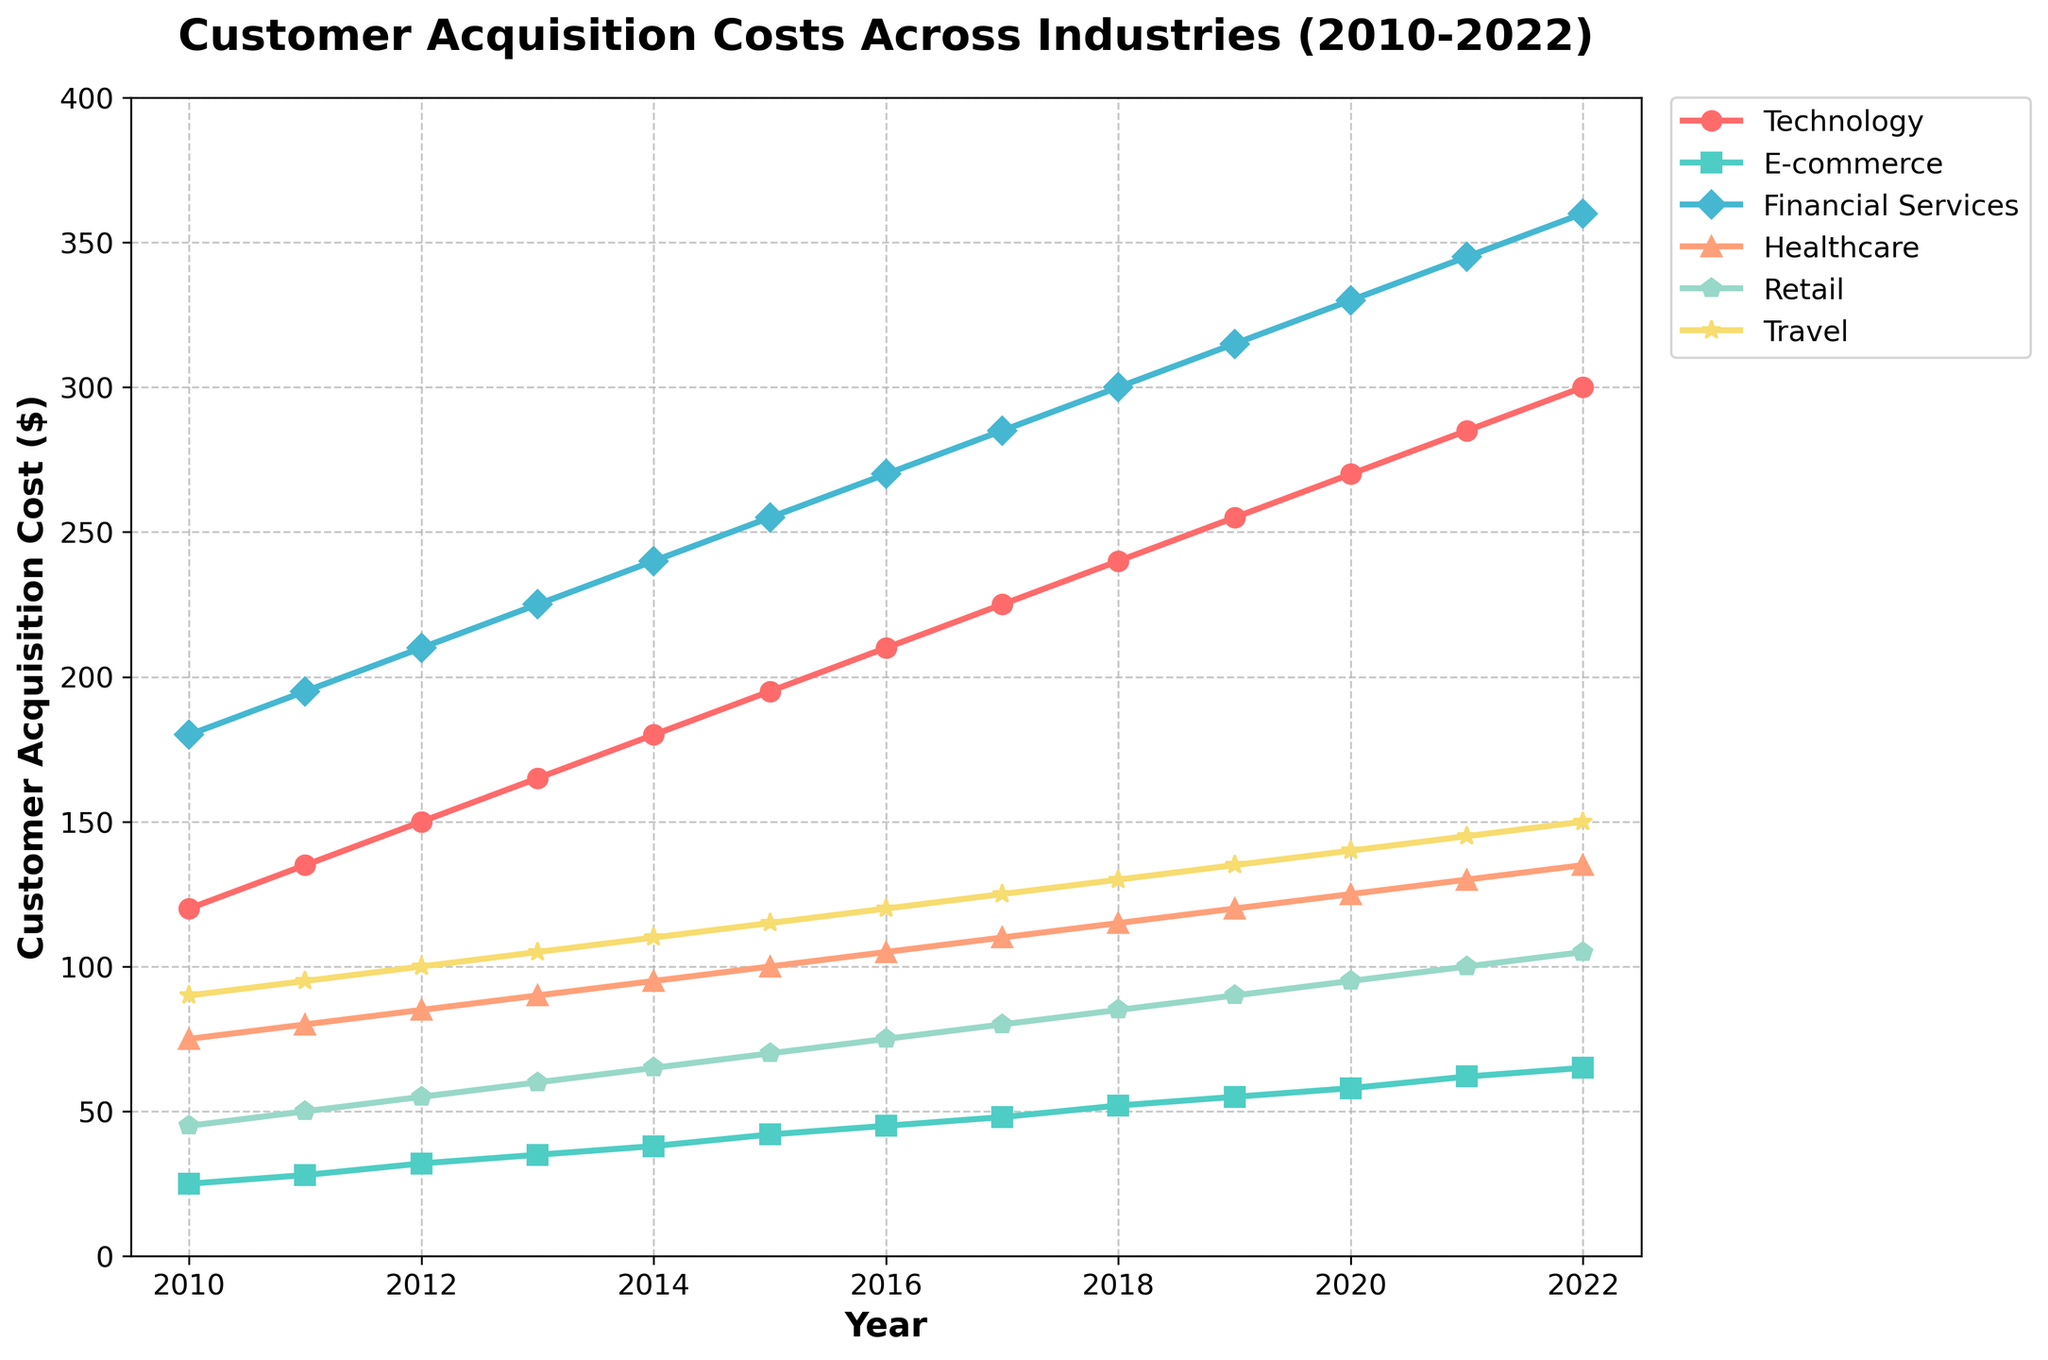What industry had the highest customer acquisition cost in 2022? By looking at the last data point for each industry, Healthcare had the highest customer acquisition cost in 2022 at $360.
Answer: Healthcare Which industry had the smallest increase in customer acquisition costs between 2010 and 2022? Subtracting the 2010 value from the 2022 value for each industry: Technology (300-120=180), E-commerce (65-25=40), Financial Services (360-180=180), Healthcare (135-75=60), Retail (105-45=60), Travel (150-90=60). E-commerce had the smallest increase (40).
Answer: E-commerce What is the trend in customer acquisition costs for the Retail industry from 2010 to 2022? The line for Retail rises steadily from 45 in 2010 to 105 in 2022.
Answer: Increasing By how much did the customer acquisition cost for the Technology industry increase from 2019 to 2022? In 2019, the cost was $255 and in 2022 it was $300. The increase is 300 - 255 = 45.
Answer: 45 Which industry showed the most consistent increase in customer acquisition costs over the years? All lines display an increasing trend, but Technology shows a very steady and consistent increase without any sharp spikes or dips.
Answer: Technology Between 2010 and 2020, what was the average customer acquisition cost for Financial Services? Summing the costs for Financial Services from 2010 to 2020: 180 + 195 + 210 + 225 + 240 + 255 + 270 + 285 + 300 + 315 + 330 = 2805. Dividing by the number of years (11), the average is 2805 / 11 ≈ 255.
Answer: 255 What color line represents the Travel industry? The line representing the Travel industry is yellow.
Answer: Yellow Compare the customer acquisition costs for E-commerce and Retail in 2015. Which industry had higher costs? In 2015, E-commerce is at $42 and Retail is at $70. Retail had higher costs.
Answer: Retail By how much did the Healthcare industry's customer acquisition cost change from 2015 to 2022? In 2015, it was $100, and in 2022 it was $135. The change is 135 - 100 = 35.
Answer: 35 Which industry had an equal customer acquisition cost of $100 in 2021? Retail had a customer acquisition cost of $100 in 2021.
Answer: Retail 